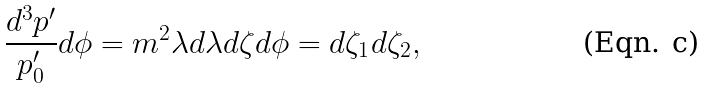<formula> <loc_0><loc_0><loc_500><loc_500>\frac { d ^ { 3 } p ^ { \prime } } { p _ { 0 } ^ { \prime } } d \phi = m ^ { 2 } \lambda d \lambda d \zeta d \phi = d \zeta _ { 1 } d \zeta _ { 2 } ,</formula> 